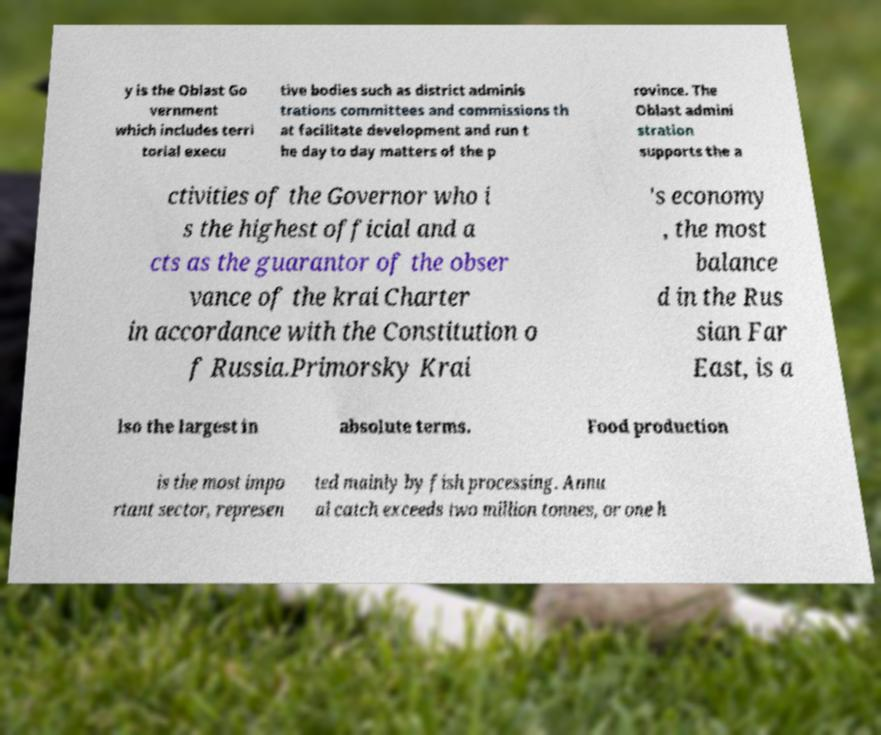Please read and relay the text visible in this image. What does it say? y is the Oblast Go vernment which includes terri torial execu tive bodies such as district adminis trations committees and commissions th at facilitate development and run t he day to day matters of the p rovince. The Oblast admini stration supports the a ctivities of the Governor who i s the highest official and a cts as the guarantor of the obser vance of the krai Charter in accordance with the Constitution o f Russia.Primorsky Krai 's economy , the most balance d in the Rus sian Far East, is a lso the largest in absolute terms. Food production is the most impo rtant sector, represen ted mainly by fish processing. Annu al catch exceeds two million tonnes, or one h 